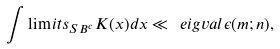Convert formula to latex. <formula><loc_0><loc_0><loc_500><loc_500>\int \lim i t s _ { S B ^ { c } } K ( x ) d x \ll \ e i g v a l \epsilon ( m ; n ) ,</formula> 